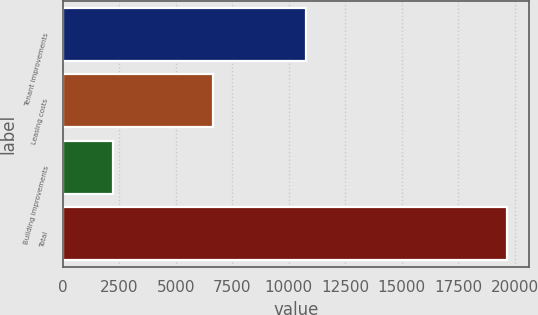Convert chart to OTSL. <chart><loc_0><loc_0><loc_500><loc_500><bar_chart><fcel>Tenant improvements<fcel>Leasing costs<fcel>Building improvements<fcel>Total<nl><fcel>10785<fcel>6655<fcel>2206<fcel>19646<nl></chart> 